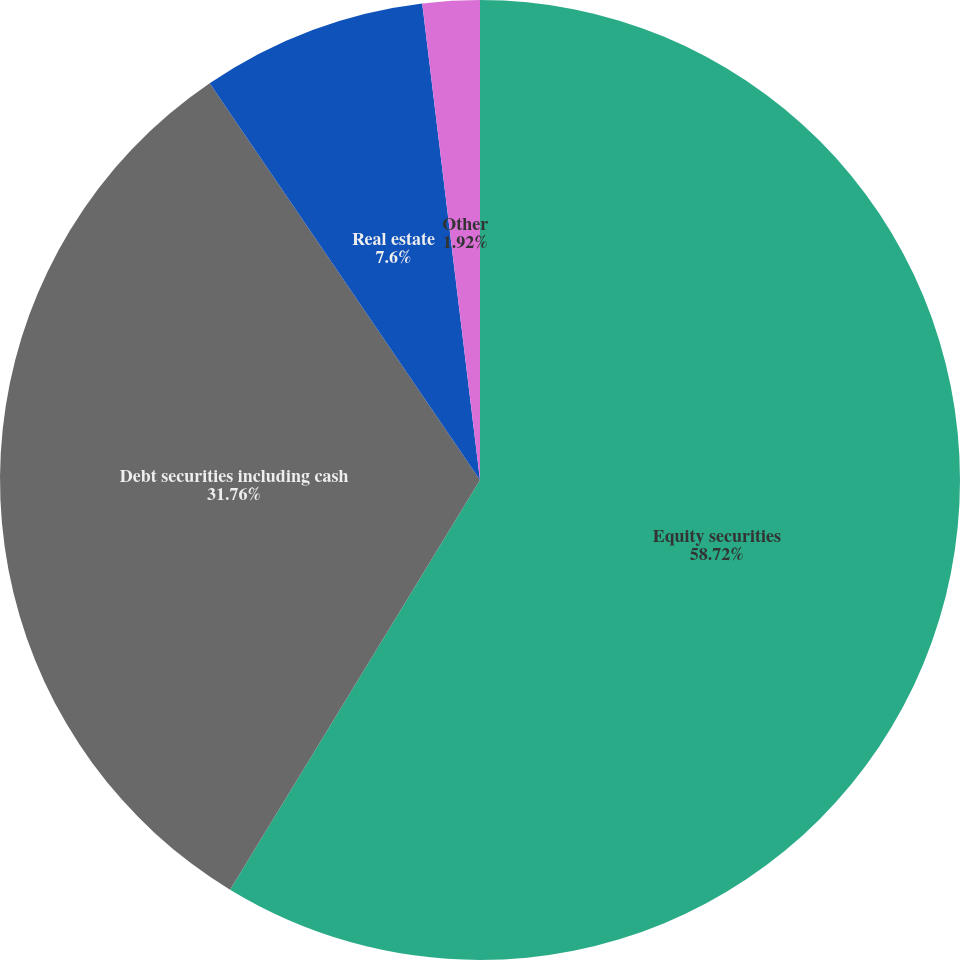<chart> <loc_0><loc_0><loc_500><loc_500><pie_chart><fcel>Equity securities<fcel>Debt securities including cash<fcel>Real estate<fcel>Other<nl><fcel>58.71%<fcel>31.76%<fcel>7.6%<fcel>1.92%<nl></chart> 